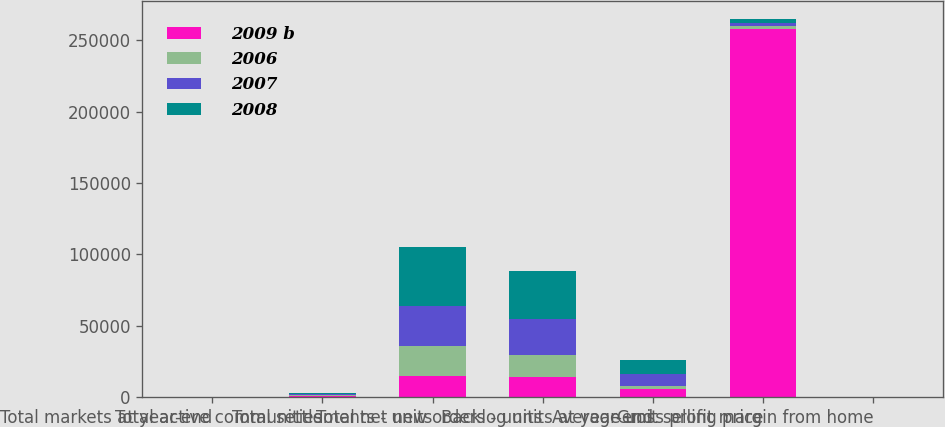Convert chart to OTSL. <chart><loc_0><loc_0><loc_500><loc_500><stacked_bar_chart><ecel><fcel>Total markets at year-end<fcel>Total active communities<fcel>Total settlements - units<fcel>Total net new orders - units<fcel>Backlog units at year-end<fcel>Average unit selling price<fcel>Gross profit margin from home<nl><fcel>2009 b<fcel>69<fcel>882<fcel>15013<fcel>14185<fcel>5931<fcel>258000<fcel>10.5<nl><fcel>2006<fcel>49<fcel>572<fcel>21022<fcel>15306<fcel>2174<fcel>2174<fcel>10.1<nl><fcel>2007<fcel>51<fcel>737<fcel>27540<fcel>25175<fcel>7890<fcel>2174<fcel>5<nl><fcel>2008<fcel>52<fcel>767<fcel>41487<fcel>33925<fcel>10255<fcel>2174<fcel>17.4<nl></chart> 